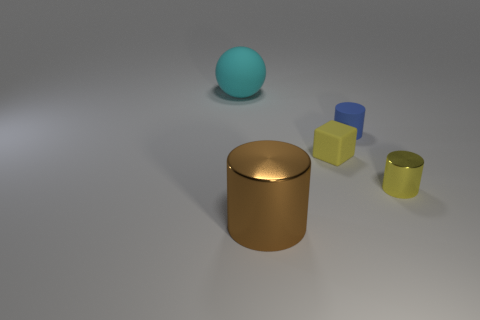What material is the cylinder that is the same color as the block?
Offer a terse response. Metal. What is the size of the cylinder that is the same color as the small cube?
Your answer should be compact. Small. What is the shape of the shiny object that is behind the large thing to the right of the ball that is to the left of the yellow metal thing?
Your response must be concise. Cylinder. Is the yellow thing behind the small yellow metallic cylinder made of the same material as the large thing on the right side of the large cyan thing?
Provide a short and direct response. No. There is a blue thing that is the same material as the block; what shape is it?
Offer a very short reply. Cylinder. Is there any other thing that has the same color as the large metal cylinder?
Ensure brevity in your answer.  No. How many large cyan metal things are there?
Make the answer very short. 0. The large thing left of the big brown metal thing to the left of the blue thing is made of what material?
Your answer should be compact. Rubber. There is a large object in front of the big thing that is to the left of the big thing that is in front of the large cyan rubber thing; what color is it?
Your answer should be compact. Brown. Do the big matte ball and the block have the same color?
Offer a terse response. No. 